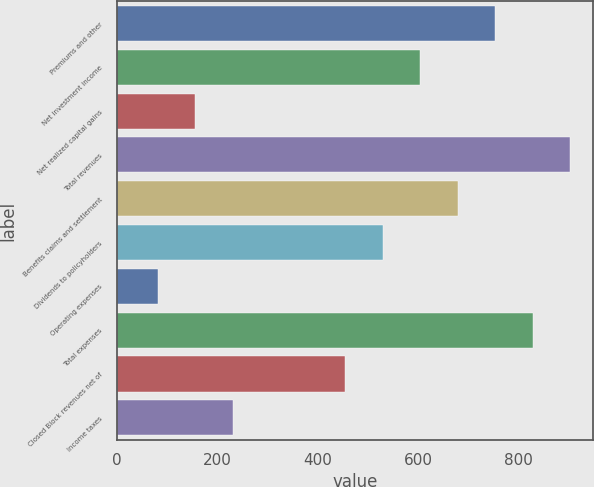<chart> <loc_0><loc_0><loc_500><loc_500><bar_chart><fcel>Premiums and other<fcel>Net investment income<fcel>Net realized capital gains<fcel>Total revenues<fcel>Benefits claims and settlement<fcel>Dividends to policyholders<fcel>Operating expenses<fcel>Total expenses<fcel>Closed Block revenues net of<fcel>Income taxes<nl><fcel>753.7<fcel>604.28<fcel>156.02<fcel>903.12<fcel>678.99<fcel>529.57<fcel>81.31<fcel>828.41<fcel>454.86<fcel>230.73<nl></chart> 